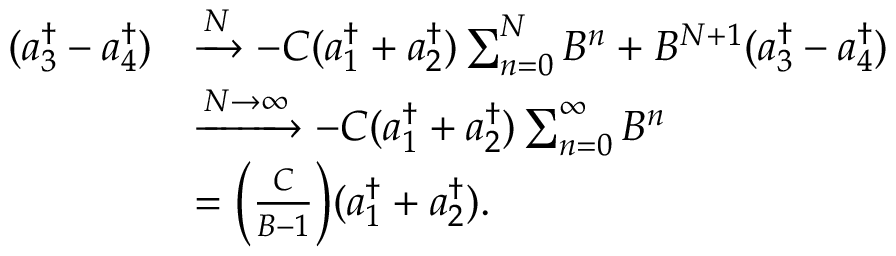Convert formula to latex. <formula><loc_0><loc_0><loc_500><loc_500>\begin{array} { r l } { ( a _ { 3 } ^ { \dagger } - a _ { 4 } ^ { \dagger } ) } & { \xrightarrow { N } - C ( a _ { 1 } ^ { \dagger } + a _ { 2 } ^ { \dagger } ) \sum _ { n = 0 } ^ { N } B ^ { n } + B ^ { N + 1 } ( a _ { 3 } ^ { \dagger } - a _ { 4 } ^ { \dagger } ) } \\ & { \xrightarrow { N \rightarrow \infty } - C ( a _ { 1 } ^ { \dagger } + a _ { 2 } ^ { \dagger } ) \sum _ { n = 0 } ^ { \infty } B ^ { n } } \\ & { = \left ( \frac { C } { B - 1 } \right ) ( a _ { 1 } ^ { \dagger } + a _ { 2 } ^ { \dagger } ) . } \end{array}</formula> 